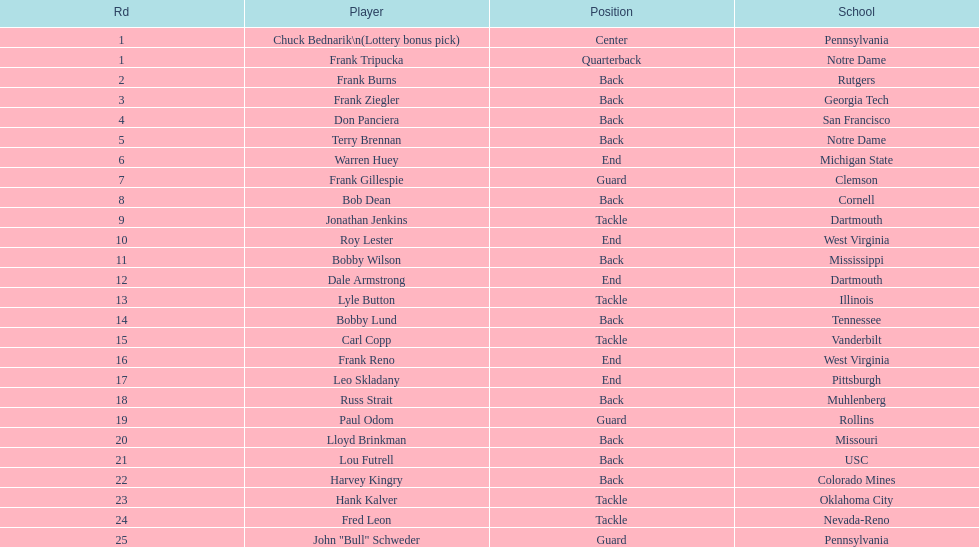Who was picked after frank burns? Frank Ziegler. 